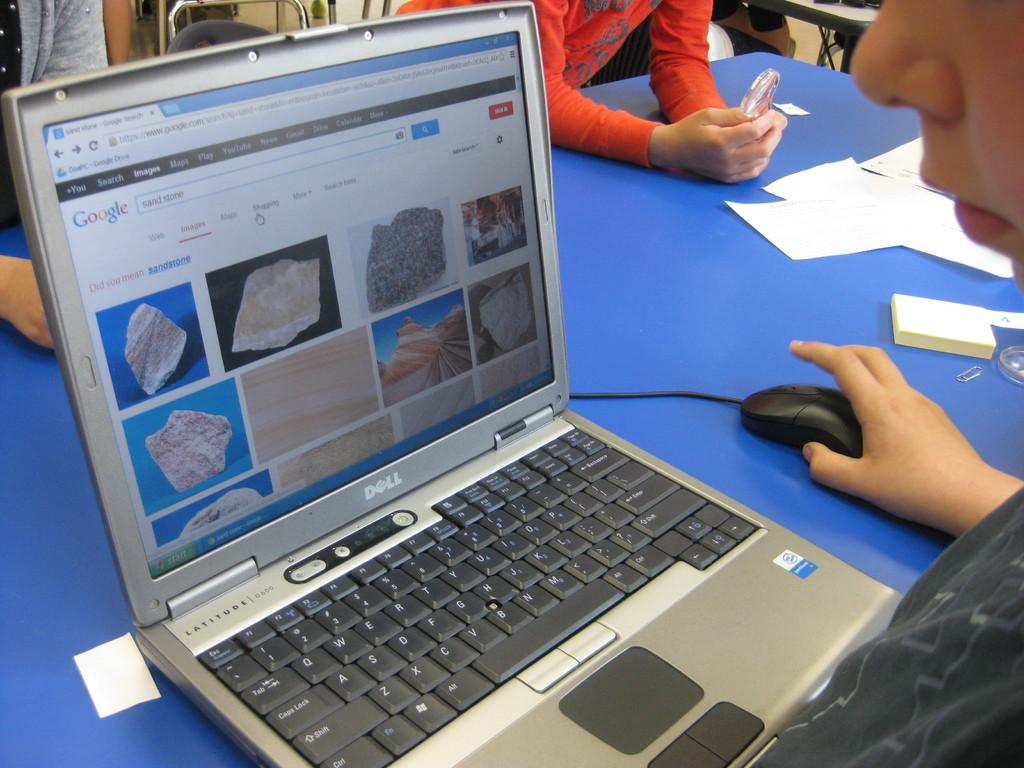Provide a one-sentence caption for the provided image. A Dell computer shows a Google search for sand stone. 